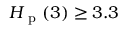<formula> <loc_0><loc_0><loc_500><loc_500>H _ { p } ( 3 ) \geq 3 . 3</formula> 